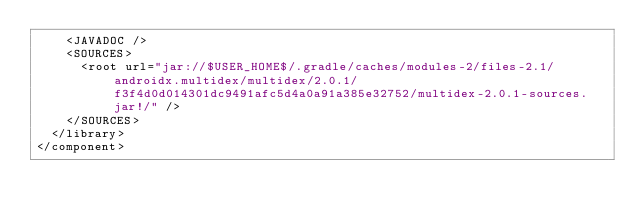Convert code to text. <code><loc_0><loc_0><loc_500><loc_500><_XML_>    <JAVADOC />
    <SOURCES>
      <root url="jar://$USER_HOME$/.gradle/caches/modules-2/files-2.1/androidx.multidex/multidex/2.0.1/f3f4d0d014301dc9491afc5d4a0a91a385e32752/multidex-2.0.1-sources.jar!/" />
    </SOURCES>
  </library>
</component></code> 